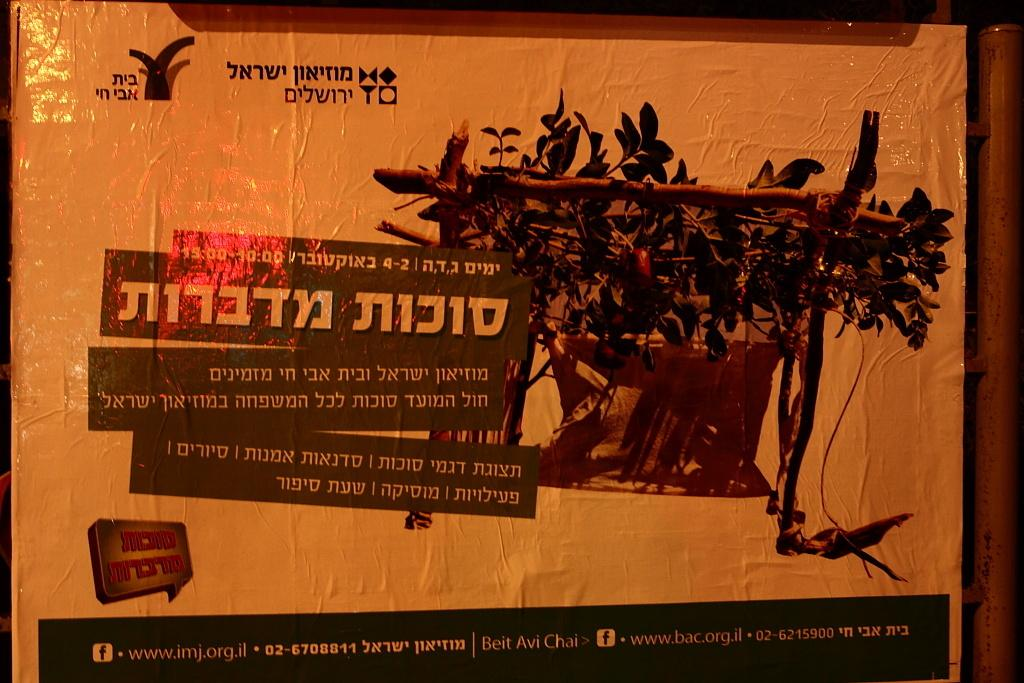What is present on the poster in the image? The poster contains images and text. Can you describe the images on the poster? Unfortunately, the specific images on the poster cannot be described without more information. What is the purpose of the text on the poster? The purpose of the text on the poster cannot be determined without more context. What is located on the right side of the image? There is a pole on the right side of the image. What type of drum is being played in the image? There is no drum present in the image; it only contains a poster and a pole. What year is depicted in the image? The year is not depicted in the image, as it only contains a poster and a pole. 